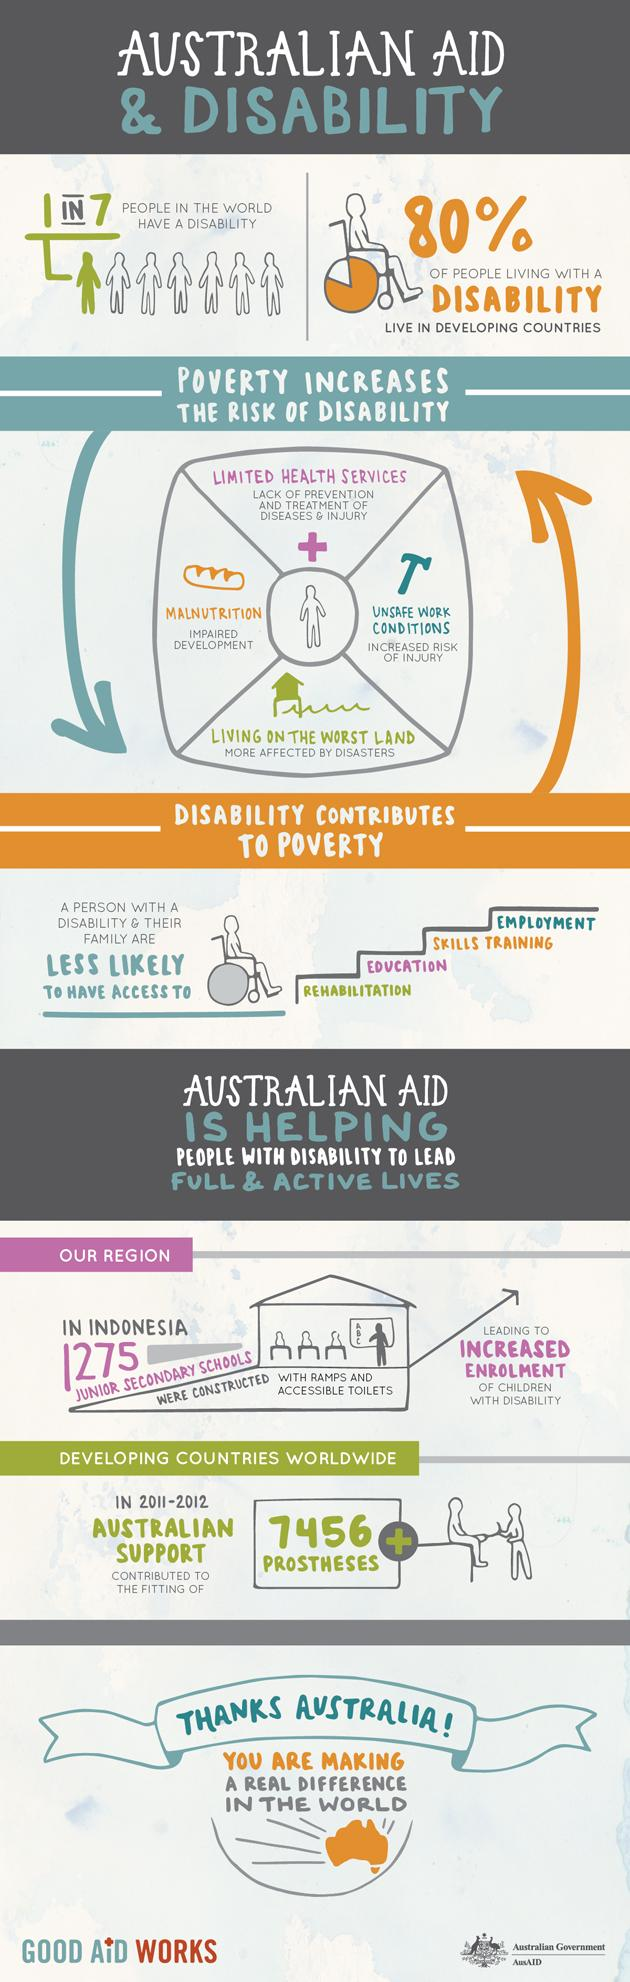Draw attention to some important aspects in this diagram. There are 1,275 schools in Indonesia designed specifically for children with disabilities. 